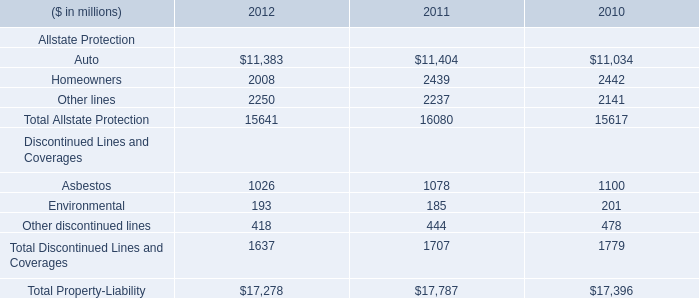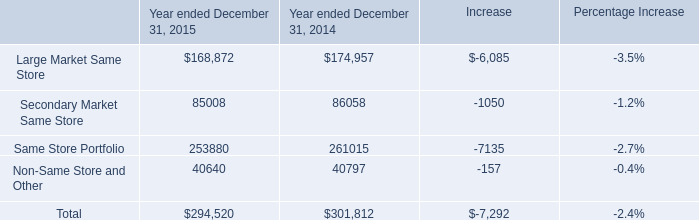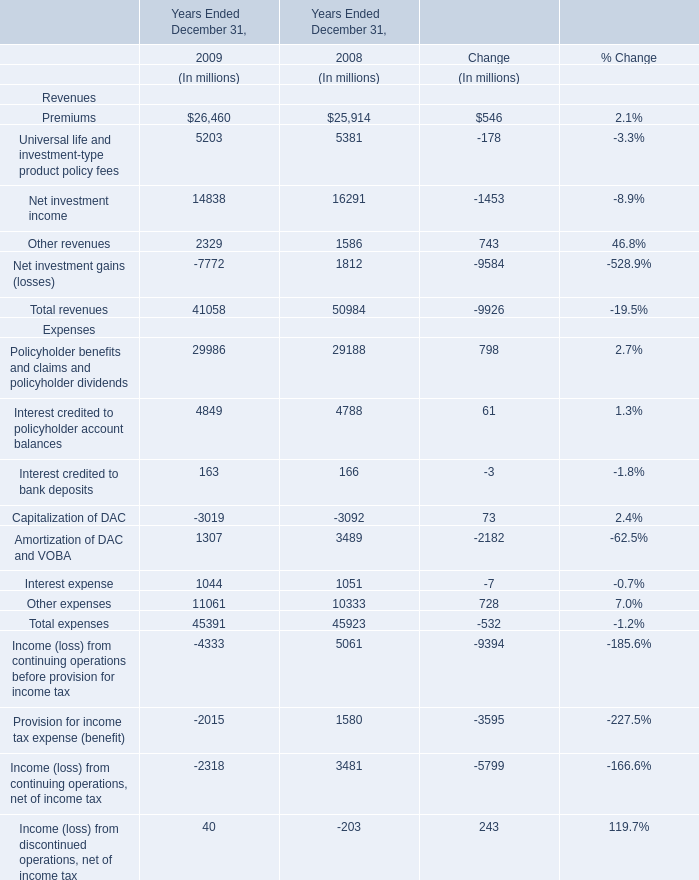What was the average value of the Net investment income, the Other revenues, the Premiums in 2008 Ended December 31 ? (in million) 
Computations: (((16291 + 1586) + 25914) / 3)
Answer: 14597.0. 